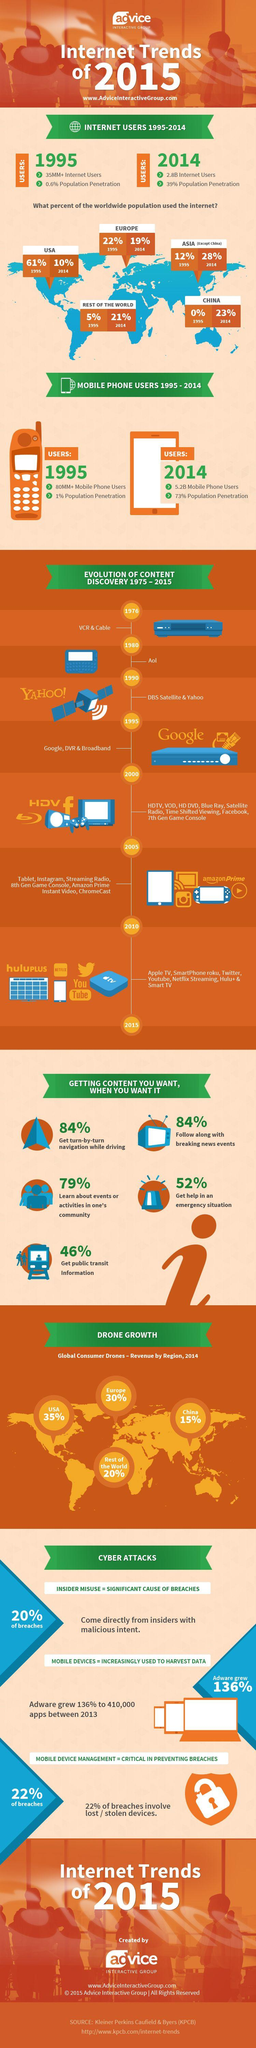Draw attention to some important aspects in this diagram. In 1995, the number of mobile phone users was estimated to be approximately 80 million and continuing to grow. In 2014, the revenue generated by the global consumer drone market in Europe was approximately 30%. In 1995, 22% of people in Europe were using the internet. In 1995, approximately 61% of people in the USA used the internet. In 2014, approximately 10% of the population in the United States used the internet. 